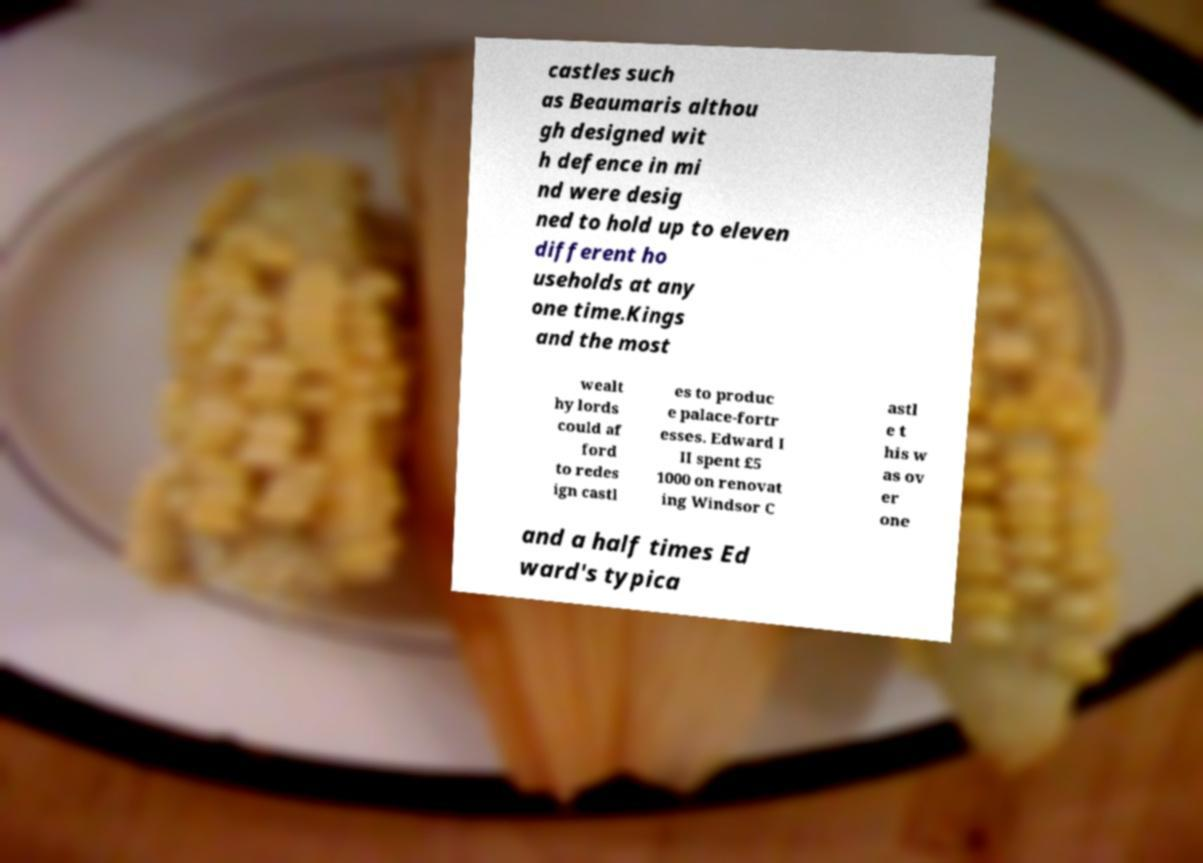Can you read and provide the text displayed in the image?This photo seems to have some interesting text. Can you extract and type it out for me? castles such as Beaumaris althou gh designed wit h defence in mi nd were desig ned to hold up to eleven different ho useholds at any one time.Kings and the most wealt hy lords could af ford to redes ign castl es to produc e palace-fortr esses. Edward I II spent £5 1000 on renovat ing Windsor C astl e t his w as ov er one and a half times Ed ward's typica 